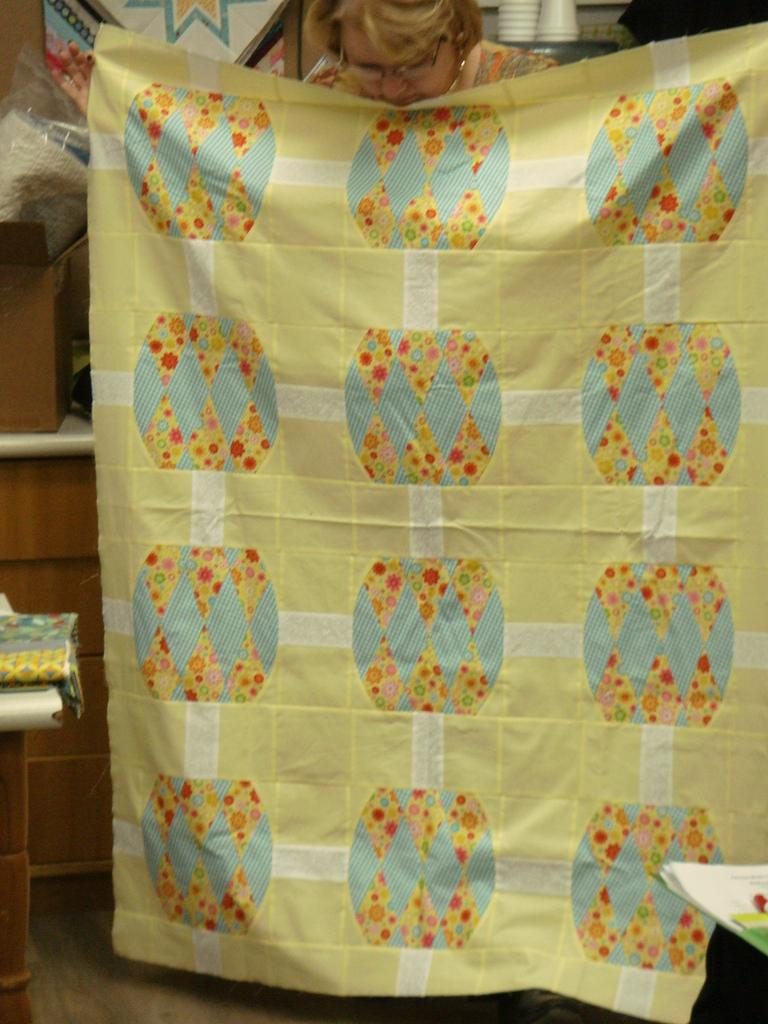What is the main subject of the image? There is a lady standing in the center of the image. What is the lady holding in the image? The lady is holding a cloth. What can be seen on the left side of the image? There are things placed on a stand on the left side of the image. What is visible in the background of the image? There is a wall and cups visible in the background of the image. What type of blood is visible on the lady's hands in the image? There is no blood visible on the lady's hands in the image. What is the lady's reaction to the loud noise in the image? There is no noise or reaction to it in the image, as it only shows the lady standing and holding a cloth. 